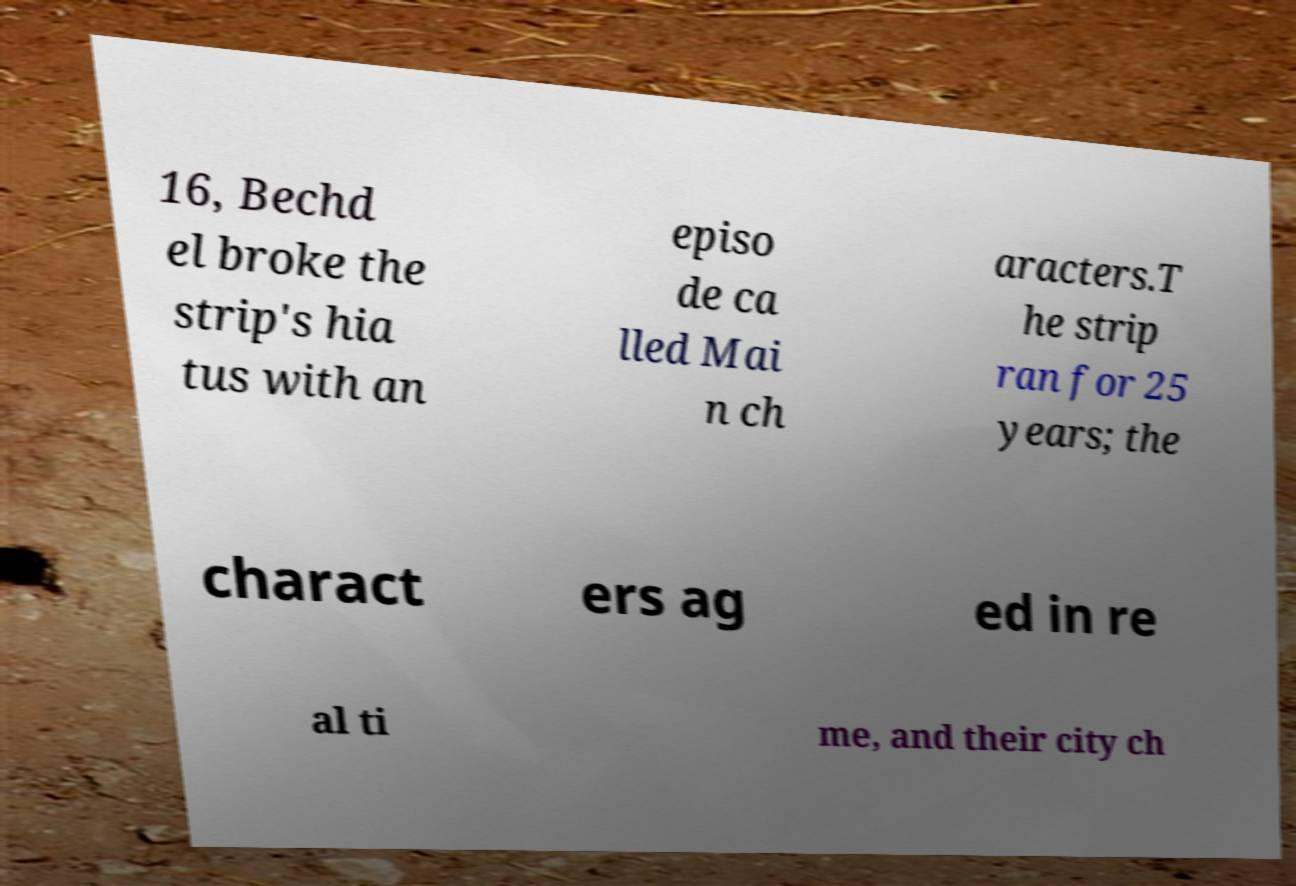For documentation purposes, I need the text within this image transcribed. Could you provide that? 16, Bechd el broke the strip's hia tus with an episo de ca lled Mai n ch aracters.T he strip ran for 25 years; the charact ers ag ed in re al ti me, and their city ch 